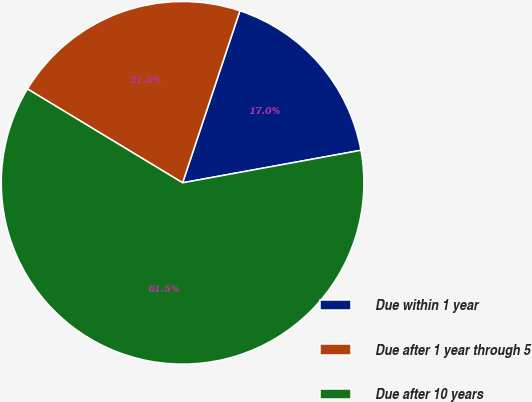Convert chart to OTSL. <chart><loc_0><loc_0><loc_500><loc_500><pie_chart><fcel>Due within 1 year<fcel>Due after 1 year through 5<fcel>Due after 10 years<nl><fcel>17.01%<fcel>21.46%<fcel>61.53%<nl></chart> 